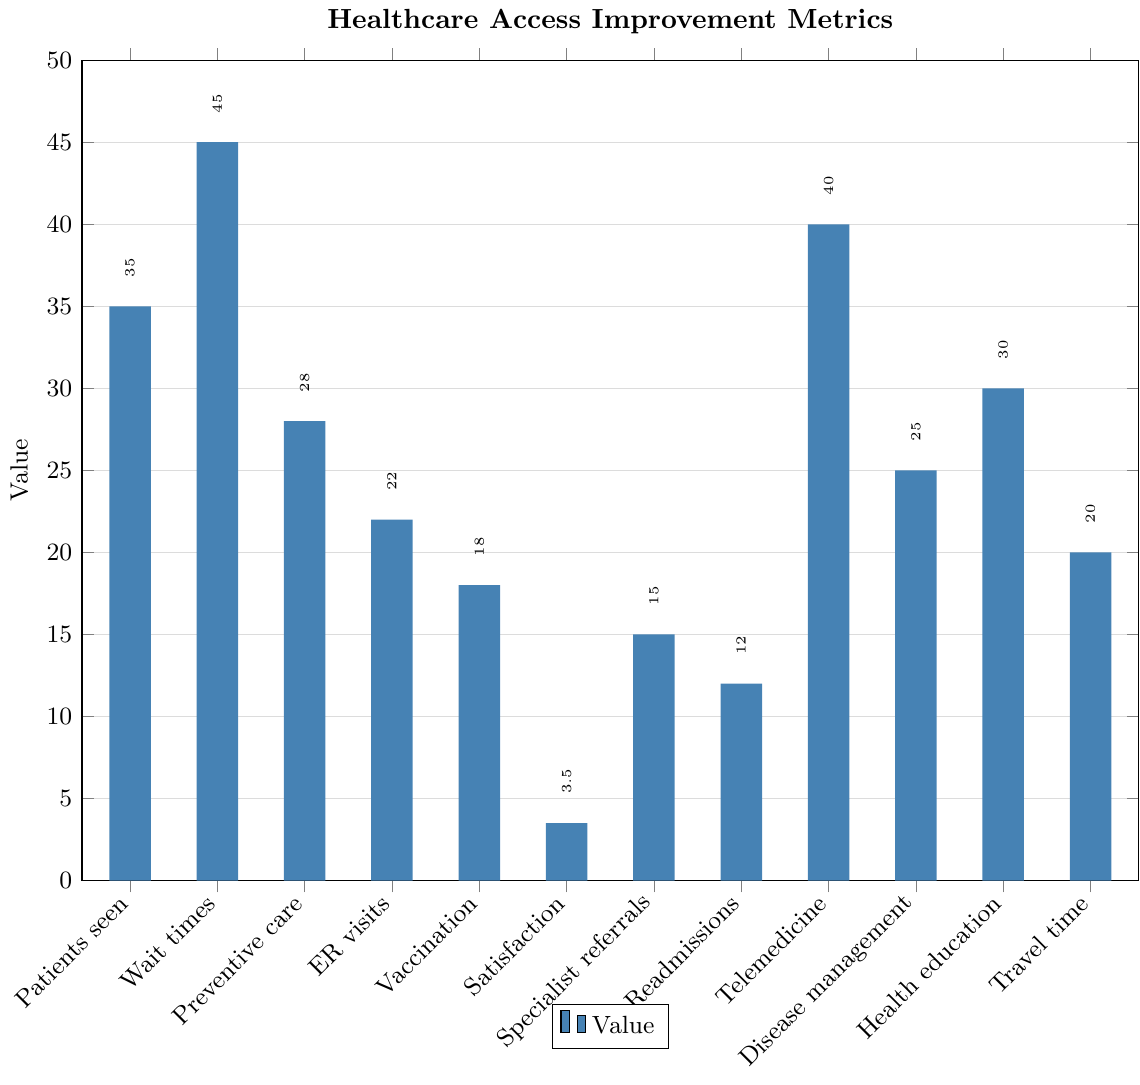What's the highest metric value and which metric does it correspond to? The bars represent different metrics, and the height indicates their values. The tallest bar corresponds to a value of 45 for "Reduction in average wait times".
Answer: 45, Reduction in average wait times How much did the percentage of preventive care visits increase? Look for the bar labeled "Preventive care" and note its height. The label at the top indicates the value, which is 28%.
Answer: 28% Which metric showed the smallest improvement? The bar with the smallest height indicates the smallest improvement. This corresponds to "Improvement in patient satisfaction scores" with a value of 3.5.
Answer: Improvement in patient satisfaction scores, 3.5 What's the difference between the increase in telemedicine consultations and the reduction in hospital readmissions? Find the values for "Telemedicine" (40) and "Readmissions" (12). Subtract the smaller value from the larger one: 40 - 12 = 28.
Answer: 28 Which metrics have values greater than 30? Identify the bars with values over 30 by reading their labels and heights: "Patients seen" (35), "Wait times" (45), "Telemedicine" (40), and "Health education" (30).
Answer: Patients seen, Wait times, Telemedicine, Health education By how many minutes did the reduction in average wait times exceed the reduction in travel time to the nearest healthcare facility? Find the bars for "Wait times" (45) and "Travel time" (20). Subtract the smaller value from the larger: 45 - 20 = 25.
Answer: 25 minutes What's the combined increase for patients seen and the increase in telemedicine consultations? Add the values for "Patients seen" (35) and "Telemedicine" (40): 35 + 40 = 75.
Answer: 75 Which metrics have improvements or reductions in the range of 10-20? Identify the bars with values between 10 and 20: "Vaccination" (18), "Specialist referrals" (15), "Readmissions" (12), "Travel time" (20).
Answer: Vaccination, Specialist referrals, Readmissions, Travel time Visualize the comparison between improvements in chronic disease management scores and patient satisfaction scores in terms of their heights. Which one is higher and by how much? Compare the height values for “Disease management” (25) and “Satisfaction” (3.5). Subtract to find the difference: 25 - 3.5 = 21.5.
Answer: Disease management is higher by 21.5 